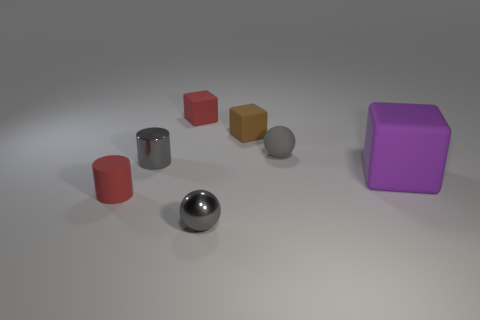Is there any other thing that has the same size as the purple object?
Offer a terse response. No. There is a small cylinder that is the same color as the metallic sphere; what is its material?
Give a very brief answer. Metal. What is the small gray object left of the gray shiny sphere made of?
Offer a terse response. Metal. What material is the red block that is the same size as the gray rubber sphere?
Your answer should be compact. Rubber. There is a small gray thing that is behind the tiny gray thing to the left of the gray object that is in front of the tiny shiny cylinder; what is it made of?
Provide a succinct answer. Rubber. Is the size of the red object in front of the rubber ball the same as the big rubber thing?
Give a very brief answer. No. Are there more tiny brown matte cubes than green matte objects?
Your response must be concise. Yes. What number of large objects are gray metallic spheres or gray cylinders?
Your answer should be very brief. 0. What number of other things are the same color as the shiny sphere?
Ensure brevity in your answer.  2. How many large cyan cubes have the same material as the big purple cube?
Make the answer very short. 0. 